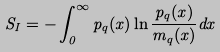Convert formula to latex. <formula><loc_0><loc_0><loc_500><loc_500>S _ { I } = - \int _ { 0 } ^ { \infty } p _ { q } ( x ) \ln \frac { p _ { q } ( x ) } { m _ { q } ( x ) } d x</formula> 